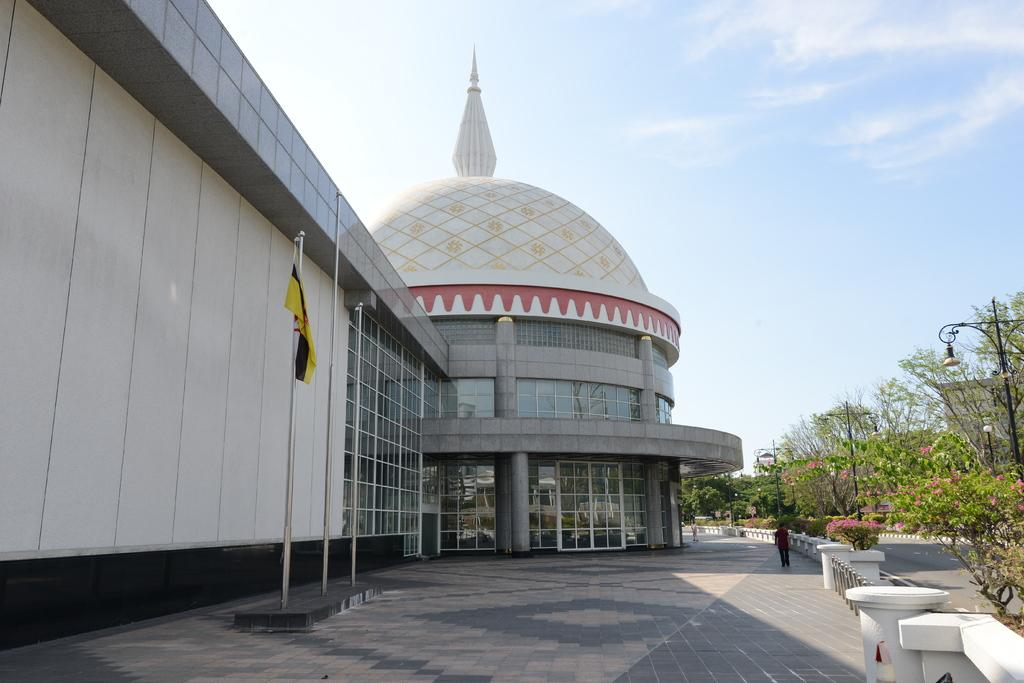What type of structure is present in the image? There is a building in the image. What other significant feature can be seen in the image? There is a tomb in the image. What type of vegetation is visible on the right side of the image? There are green color plants and trees on the right side of the image. What color is the sky in the image? The sky is blue in the image. How does the building show respect to the tomb in the image? The image does not depict any interaction between the building and the tomb, so it cannot be determined how the building shows respect. 